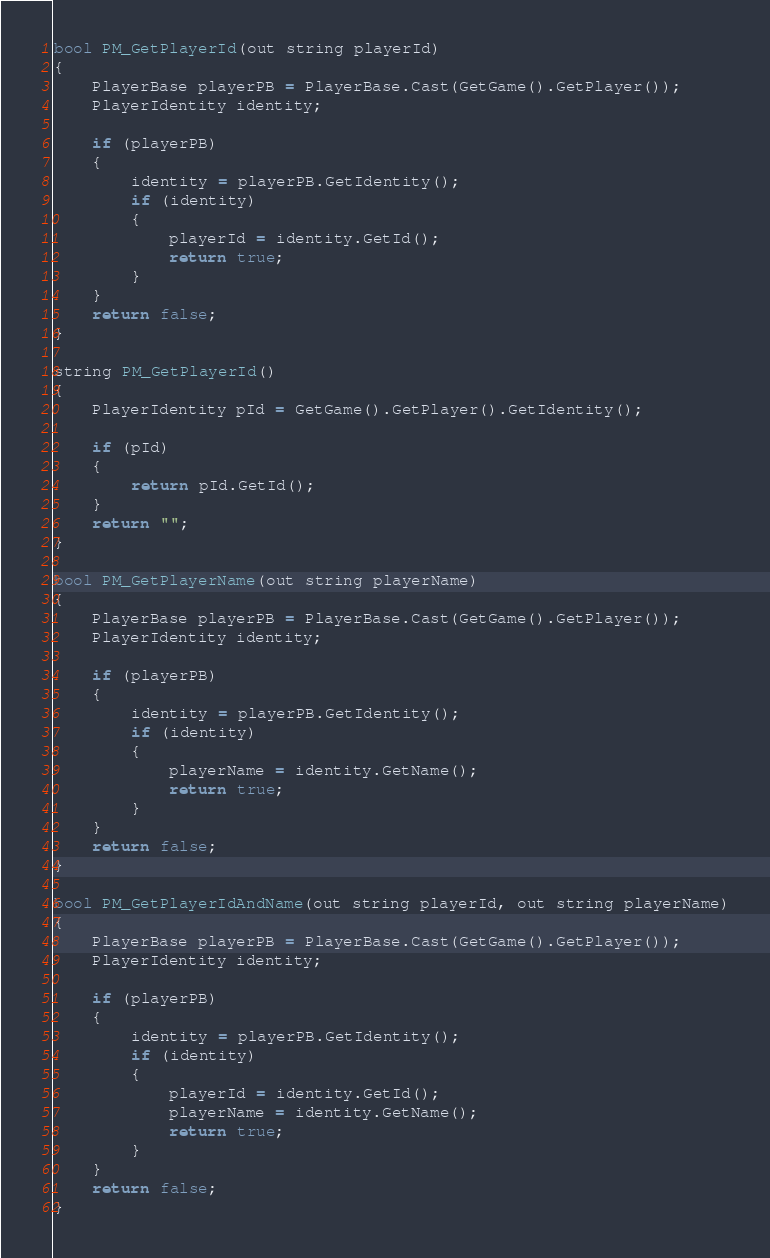Convert code to text. <code><loc_0><loc_0><loc_500><loc_500><_C_>bool PM_GetPlayerId(out string playerId)
{
    PlayerBase playerPB = PlayerBase.Cast(GetGame().GetPlayer());
    PlayerIdentity identity;

    if (playerPB)
    {
        identity = playerPB.GetIdentity();
        if (identity)
        {
            playerId = identity.GetId();
            return true;
        }
    }
    return false;
}

string PM_GetPlayerId()
{
	PlayerIdentity pId = GetGame().GetPlayer().GetIdentity();
	
	if (pId)
	{
		return pId.GetId();
	}
	return "";
}

bool PM_GetPlayerName(out string playerName)
{
    PlayerBase playerPB = PlayerBase.Cast(GetGame().GetPlayer());
    PlayerIdentity identity;

    if (playerPB)
    {
        identity = playerPB.GetIdentity();
        if (identity)
        {
            playerName = identity.GetName();
            return true;
        }
    }
    return false;
}

bool PM_GetPlayerIdAndName(out string playerId, out string playerName)
{
    PlayerBase playerPB = PlayerBase.Cast(GetGame().GetPlayer());
    PlayerIdentity identity;

    if (playerPB)
    {
        identity = playerPB.GetIdentity();
        if (identity)
        {
            playerId = identity.GetId();
			playerName = identity.GetName();
            return true;
        }
    }
    return false;
}</code> 